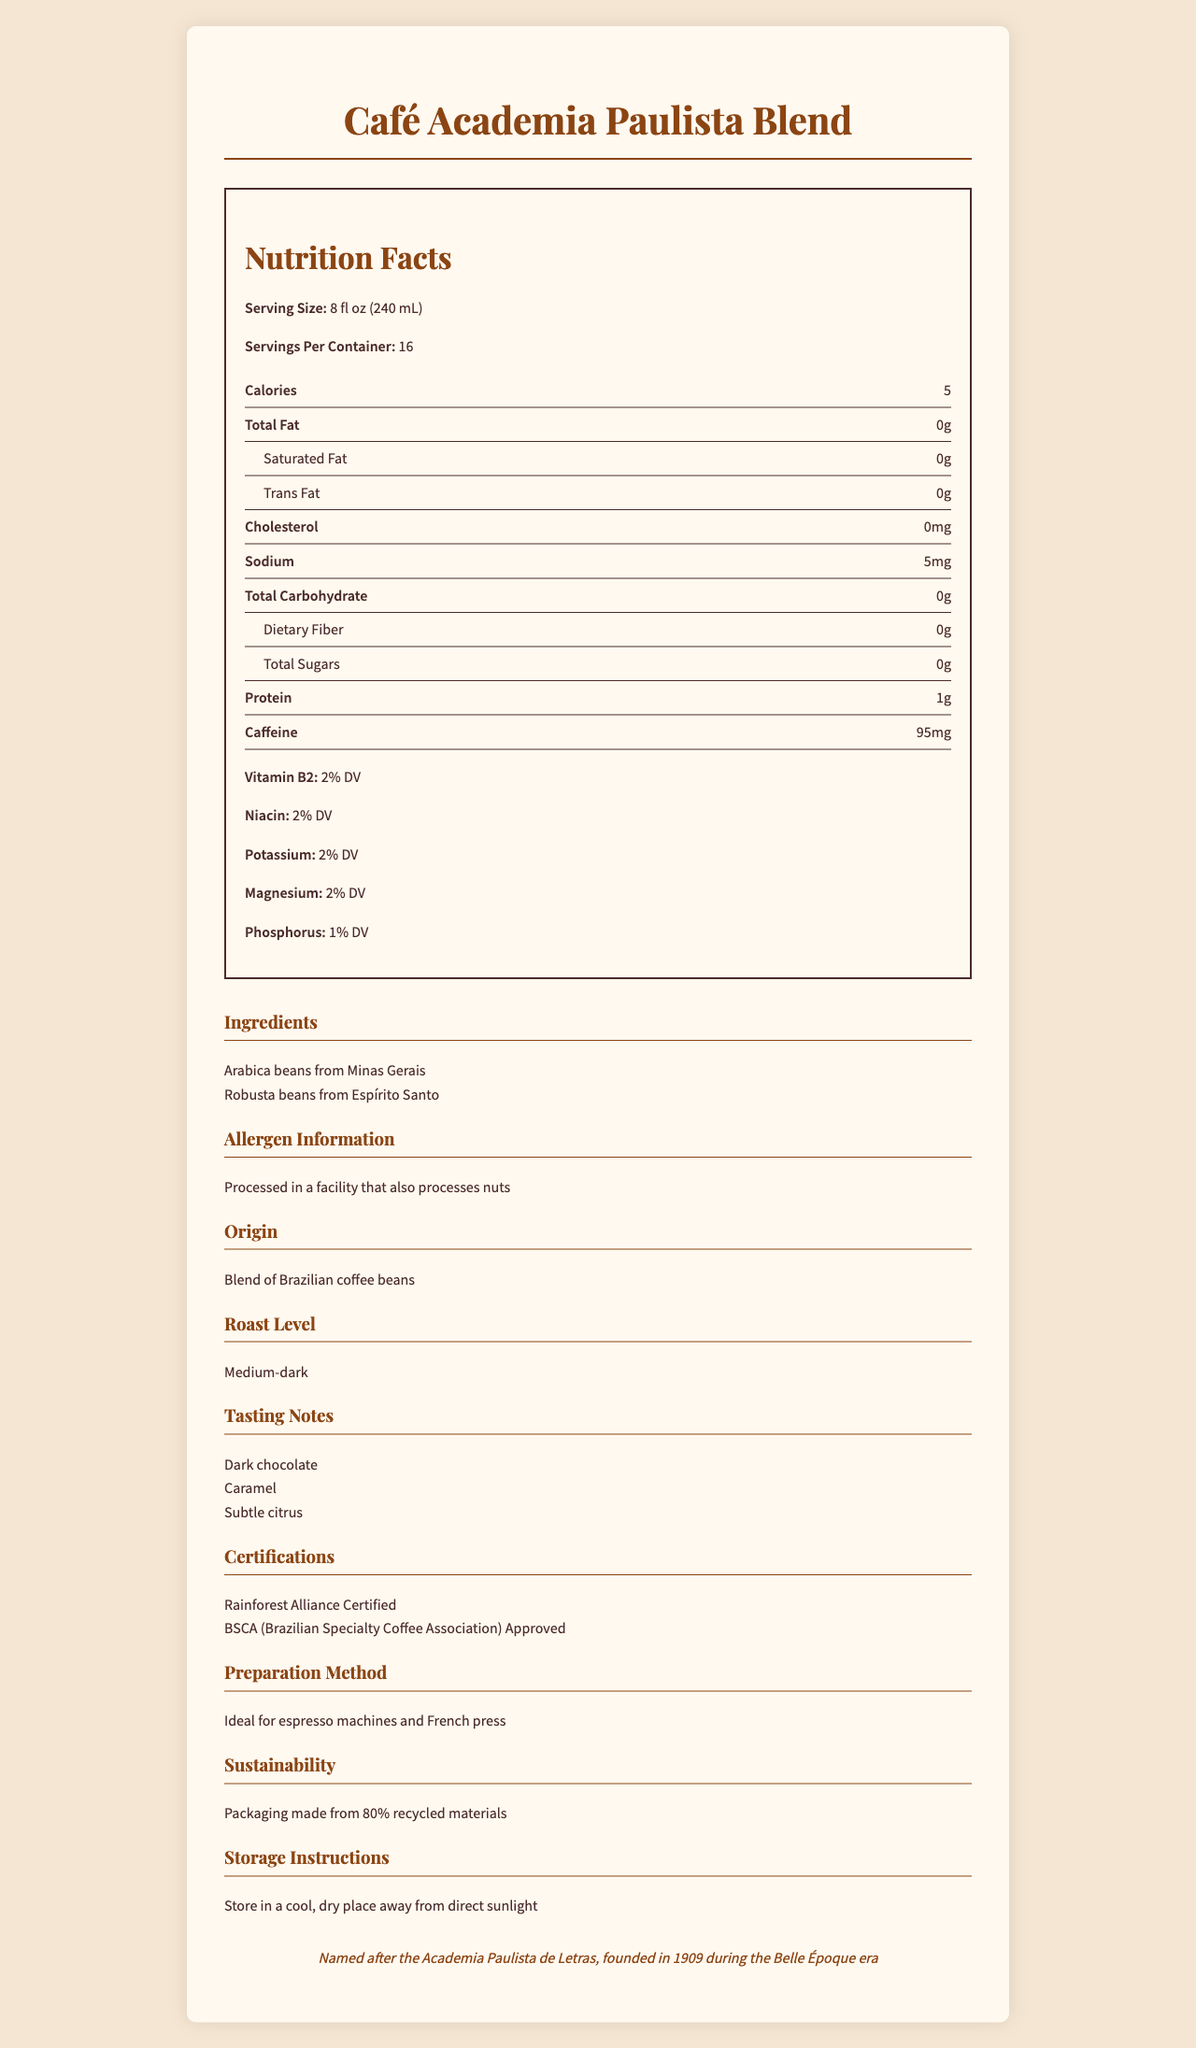what is the serving size for Café Academia Paulista Blend? The document clearly specifies the serving size as 8 fl oz (240 mL).
Answer: 8 fl oz (240 mL) how many servings are there per container? The document lists the servings per container as 16.
Answer: 16 what is the amount of caffeine per serving? The caffeine content is noted as 95 mg per serving in the document.
Answer: 95 mg what vitamin content does Café Academia Paulista Blend have? The document lists various vitamin contents along with their Daily Values (DV): Vitamin B2 (2% DV), Niacin (2% DV), Potassium (2% DV), Magnesium (2% DV), and Phosphorus (1% DV).
Answer: 2% DV for Vitamin B2, 2% DV for Niacin, 2% DV for Potassium, 2% DV for Magnesium, 1% DV for Phosphorus what are the tasting notes for this coffee blend? The tasting notes provided in the document are Dark chocolate, Caramel, and Subtle citrus.
Answer: Dark chocolate, Caramel, Subtle citrus what is the origin of the coffee beans used in this blend?
 A. Colombia
 B. Brazil
 C. Ethiopia
 D. Costa Rica The document states the origin as "Blend of Brazilian coffee beans".
Answer: B. Brazil what is the roast level of this coffee blend?
 I. Light
 II. Medium
 III. Medium-dark
 IV. Dark The document specifies the roast level as Medium-dark.
Answer: III. Medium-dark is the coffee blend free from nuts? The allergen information states that it is processed in a facility that also processes nuts, indicating it may not be free from nuts.
Answer: No describe the certifications this coffee blend has. The document lists two certifications: Rainforest Alliance Certified and BSCA approved.
Answer: Rainforest Alliance Certified, BSCA (Brazilian Specialty Coffee Association) Approved how many calories are in one serving of Café Academia Paulista Blend? The document lists the calorie content per serving as 5.
Answer: 5 what preparation methods are ideal for this coffee? The document states that the ideal preparation methods are for espresso machines and French press.
Answer: Espresso machines and French press what is the source of the Arabica beans used in the blend? The document lists Arabica beans from Minas Gerais as one of the ingredients.
Answer: Minas Gerais is the coffee blend processed in a nut-free facility? The allergen information in the document states that it is processed in a facility that also processes nuts.
Answer: No is the coffee blend primarily composed of Robusta beans? The document lists both Arabica and Robusta beans as ingredients but does not specify the proportions.
Answer: Cannot be determined summarize the main features of Café Academia Paulista Blend. The document provides detailed information on the product's serving size, nutritional values, ingredients, tasting notes, certifications, preparation methods, allergen information, and sustainability measures.
Answer: Café Academia Paulista Blend is a medium-dark roast coffee made from a blend of Brazilian coffee beans, specifically Arabica from Minas Gerais and Robusta from Espírito Santo. Each serving is 8 fl oz (240 mL) with 5 calories and 95 mg of caffeine. It has tasting notes of Dark chocolate, Caramel, and Subtle citrus. The blend is Rainforest Alliance Certified and BSCA Approved, and is ideal for espresso machines and French presses. The coffee is processed in a facility that also processes nuts and has packaging made from 80% recycled materials. 